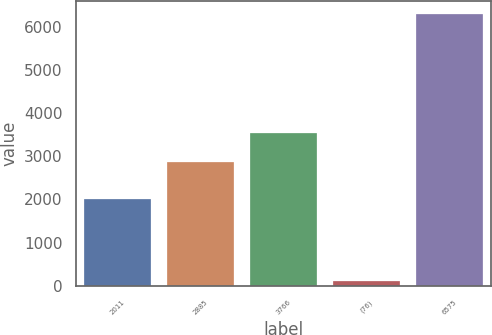Convert chart. <chart><loc_0><loc_0><loc_500><loc_500><bar_chart><fcel>2011<fcel>2885<fcel>3766<fcel>(76)<fcel>6575<nl><fcel>2009<fcel>2865<fcel>3534<fcel>107<fcel>6292<nl></chart> 